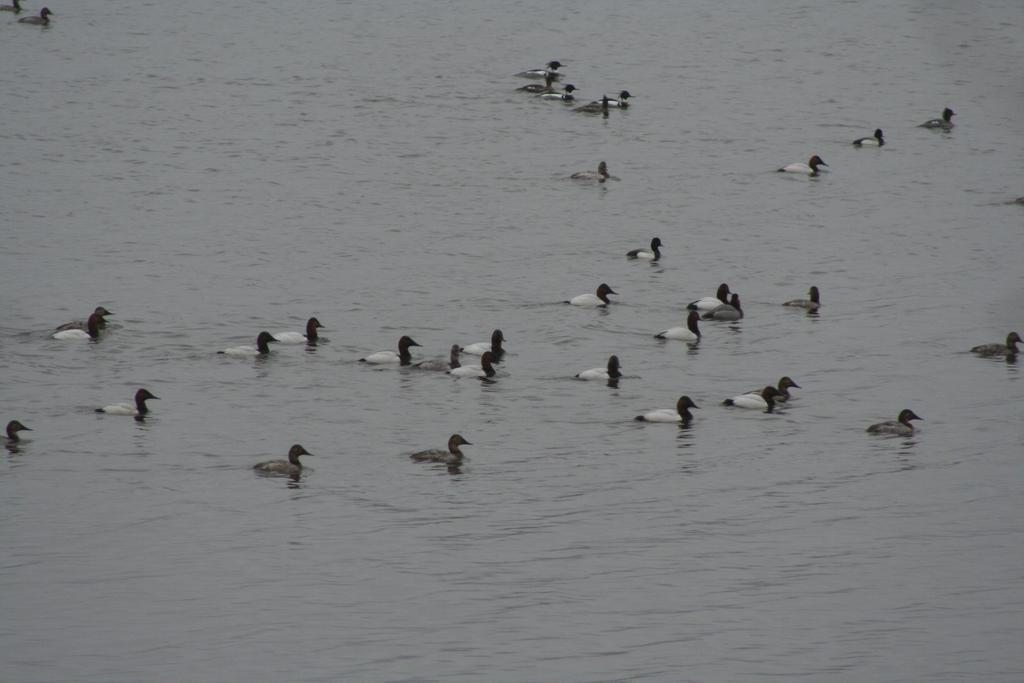Where was the image taken? The image was taken outdoors. What can be seen at the bottom of the image? There is a pond with water at the bottom of the image. What animals are present in the pond? There are many ducks in the pond in the middle of the image. What type of can is floating in the pond in the image? There is no can present in the image; it features a pond with ducks. Can you see any goats in the image? No, there are no goats present in the image. 